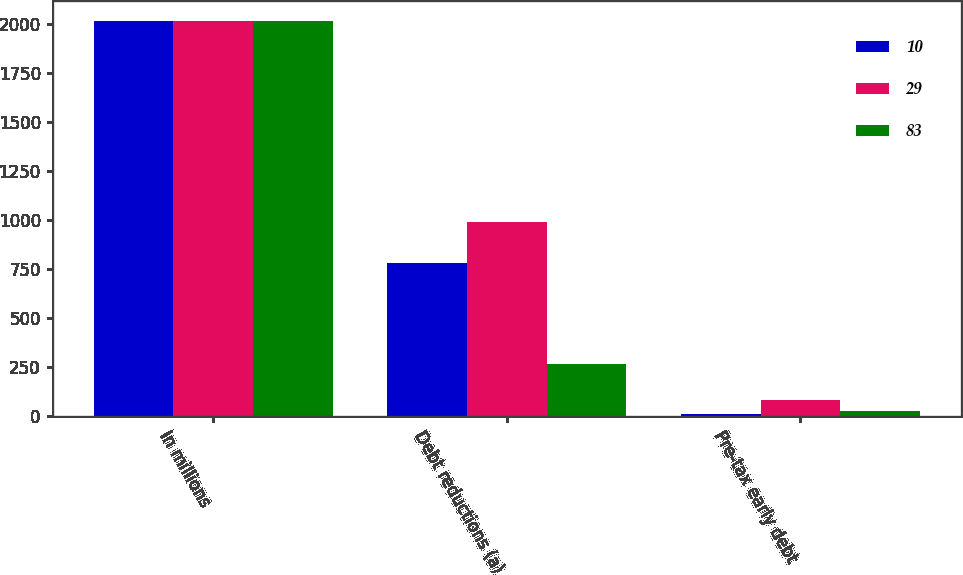Convert chart to OTSL. <chart><loc_0><loc_0><loc_500><loc_500><stacked_bar_chart><ecel><fcel>In millions<fcel>Debt reductions (a)<fcel>Pre-tax early debt<nl><fcel>10<fcel>2018<fcel>780<fcel>10<nl><fcel>29<fcel>2017<fcel>993<fcel>83<nl><fcel>83<fcel>2016<fcel>266<fcel>29<nl></chart> 